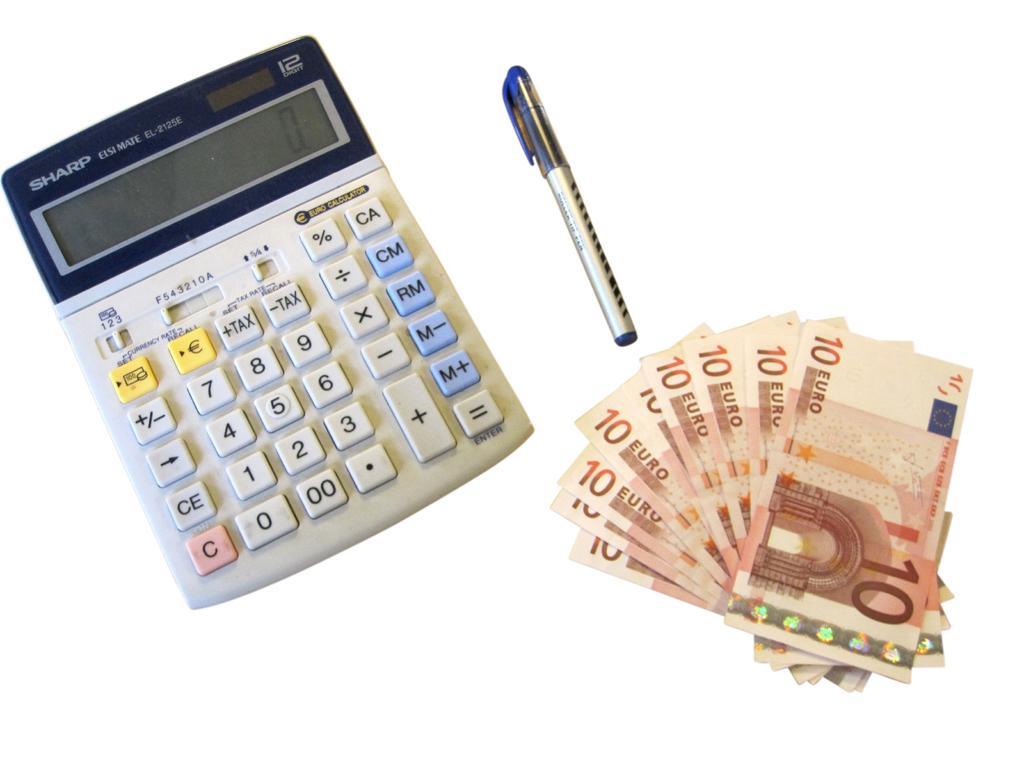Can you describe this image briefly? In this picture I can see there is some money, a pen and a calculator with buttons and it has a screen. 